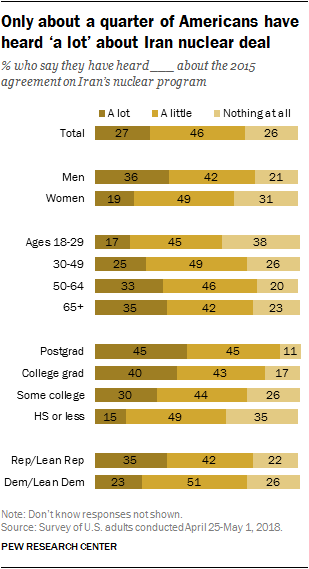Mention a couple of crucial points in this snapshot. A significant number of men, approximately 36, have heard a great deal about the 2015 agreement on Iran's nuclear program. The value is greater than nothing in the age group 30-49. 